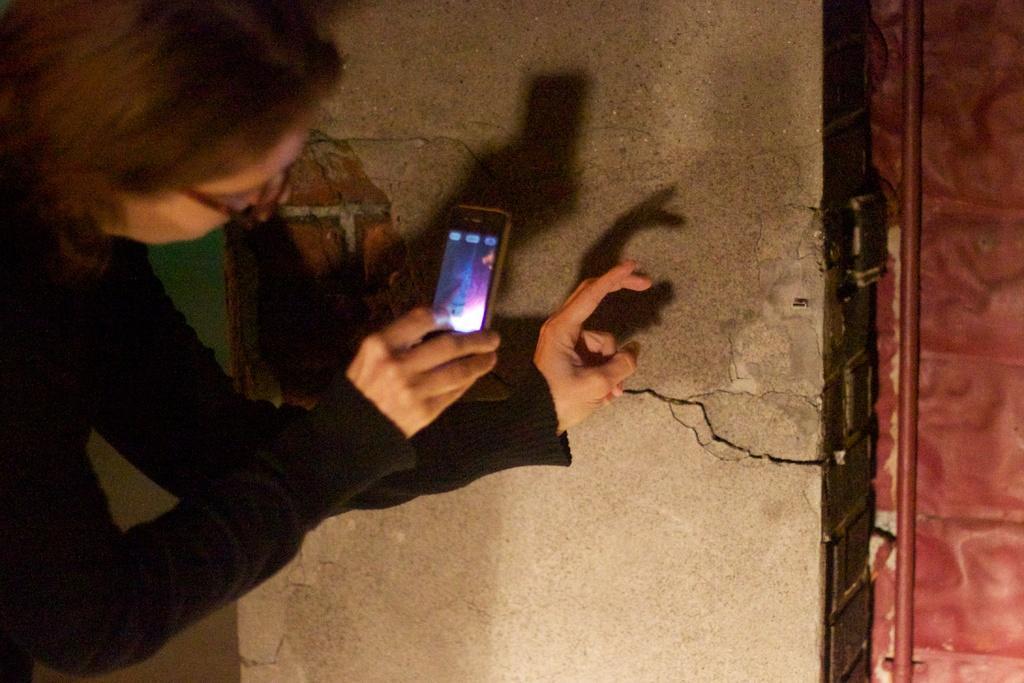Please provide a concise description of this image. In this image we can see one person is holding a mobile phone, near that we can see the wall, after that we can see a pipeline. 